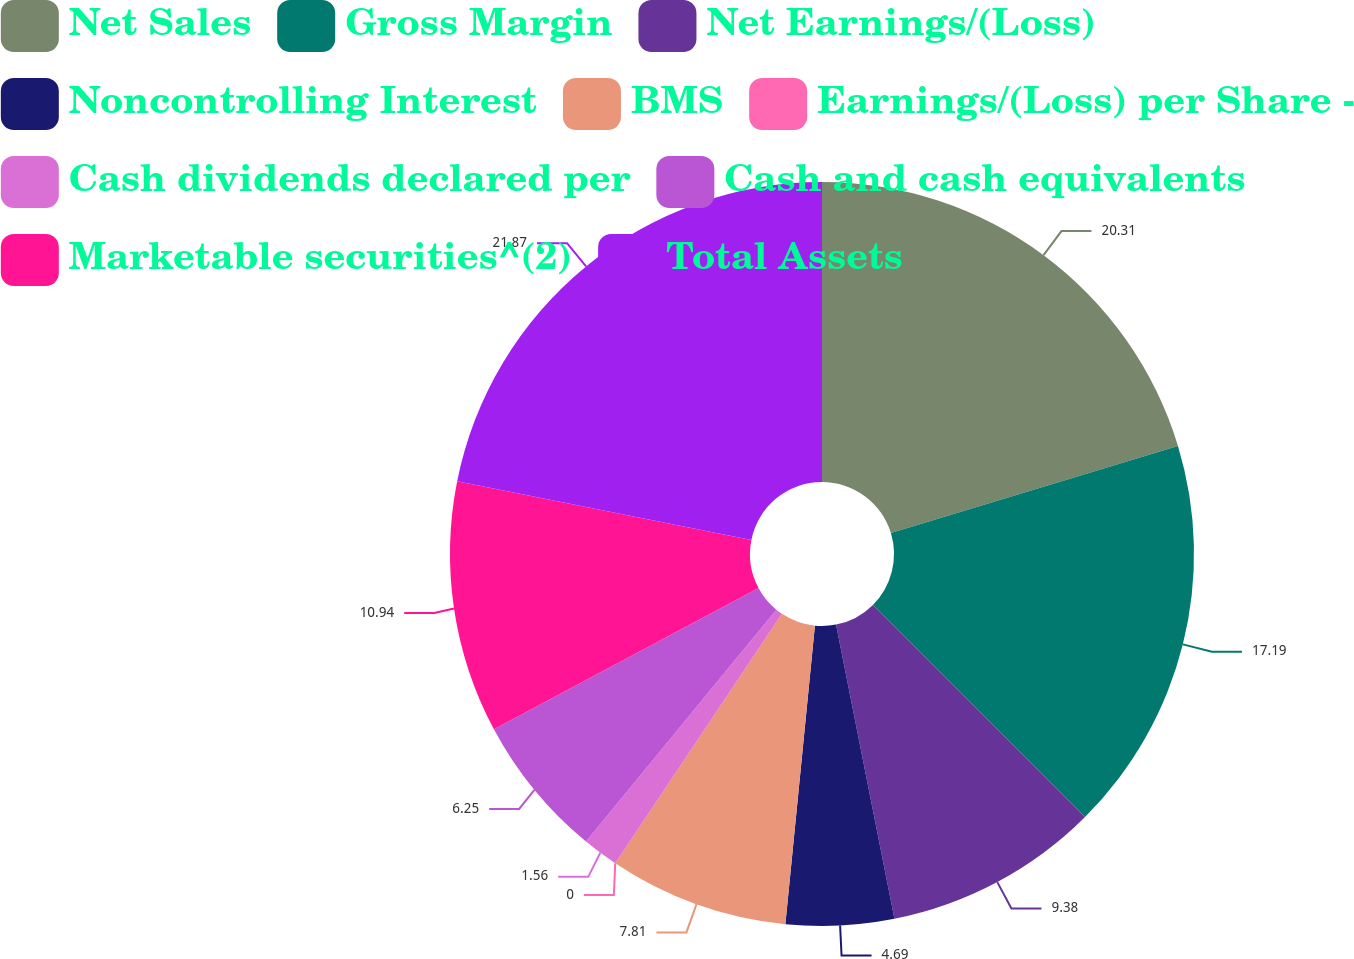<chart> <loc_0><loc_0><loc_500><loc_500><pie_chart><fcel>Net Sales<fcel>Gross Margin<fcel>Net Earnings/(Loss)<fcel>Noncontrolling Interest<fcel>BMS<fcel>Earnings/(Loss) per Share -<fcel>Cash dividends declared per<fcel>Cash and cash equivalents<fcel>Marketable securities^(2)<fcel>Total Assets<nl><fcel>20.31%<fcel>17.19%<fcel>9.38%<fcel>4.69%<fcel>7.81%<fcel>0.0%<fcel>1.56%<fcel>6.25%<fcel>10.94%<fcel>21.87%<nl></chart> 